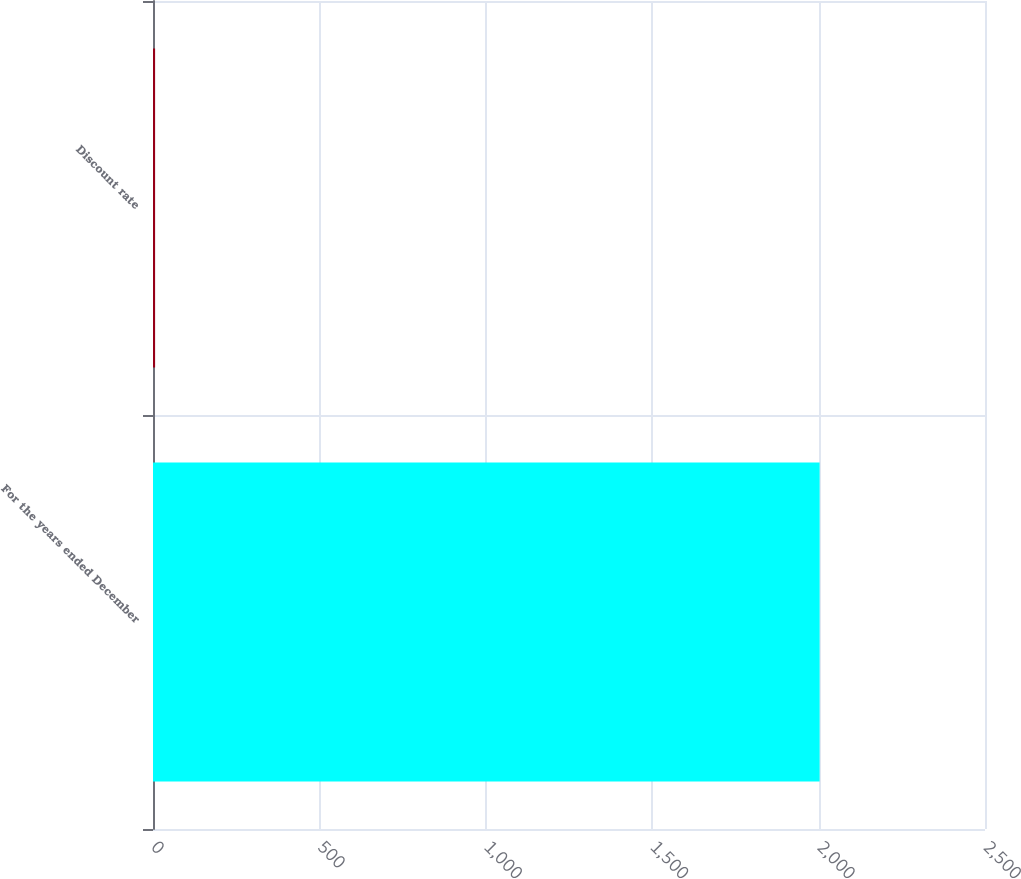<chart> <loc_0><loc_0><loc_500><loc_500><bar_chart><fcel>For the years ended December<fcel>Discount rate<nl><fcel>2003<fcel>6.3<nl></chart> 